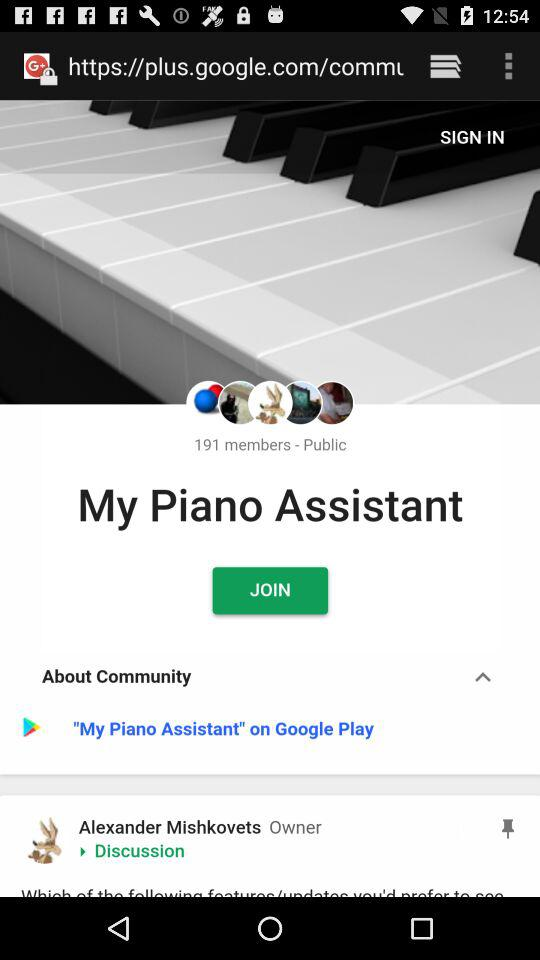Where could we download "My Piano Assistant"? You can download "My Piano Assistant" from "Google Play". 